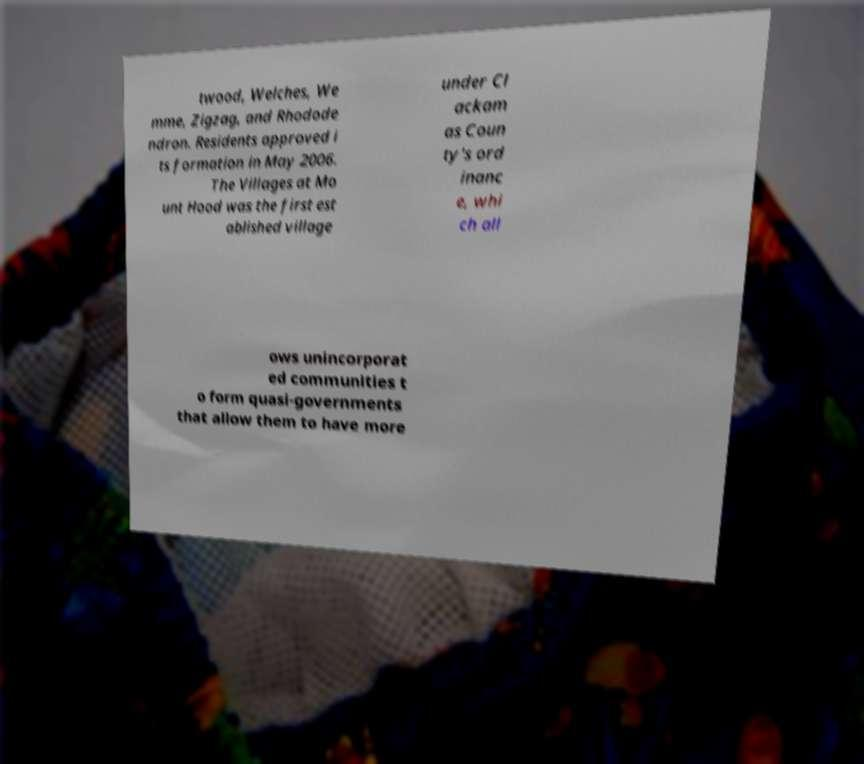Could you extract and type out the text from this image? twood, Welches, We mme, Zigzag, and Rhodode ndron. Residents approved i ts formation in May 2006. The Villages at Mo unt Hood was the first est ablished village under Cl ackam as Coun ty's ord inanc e, whi ch all ows unincorporat ed communities t o form quasi-governments that allow them to have more 